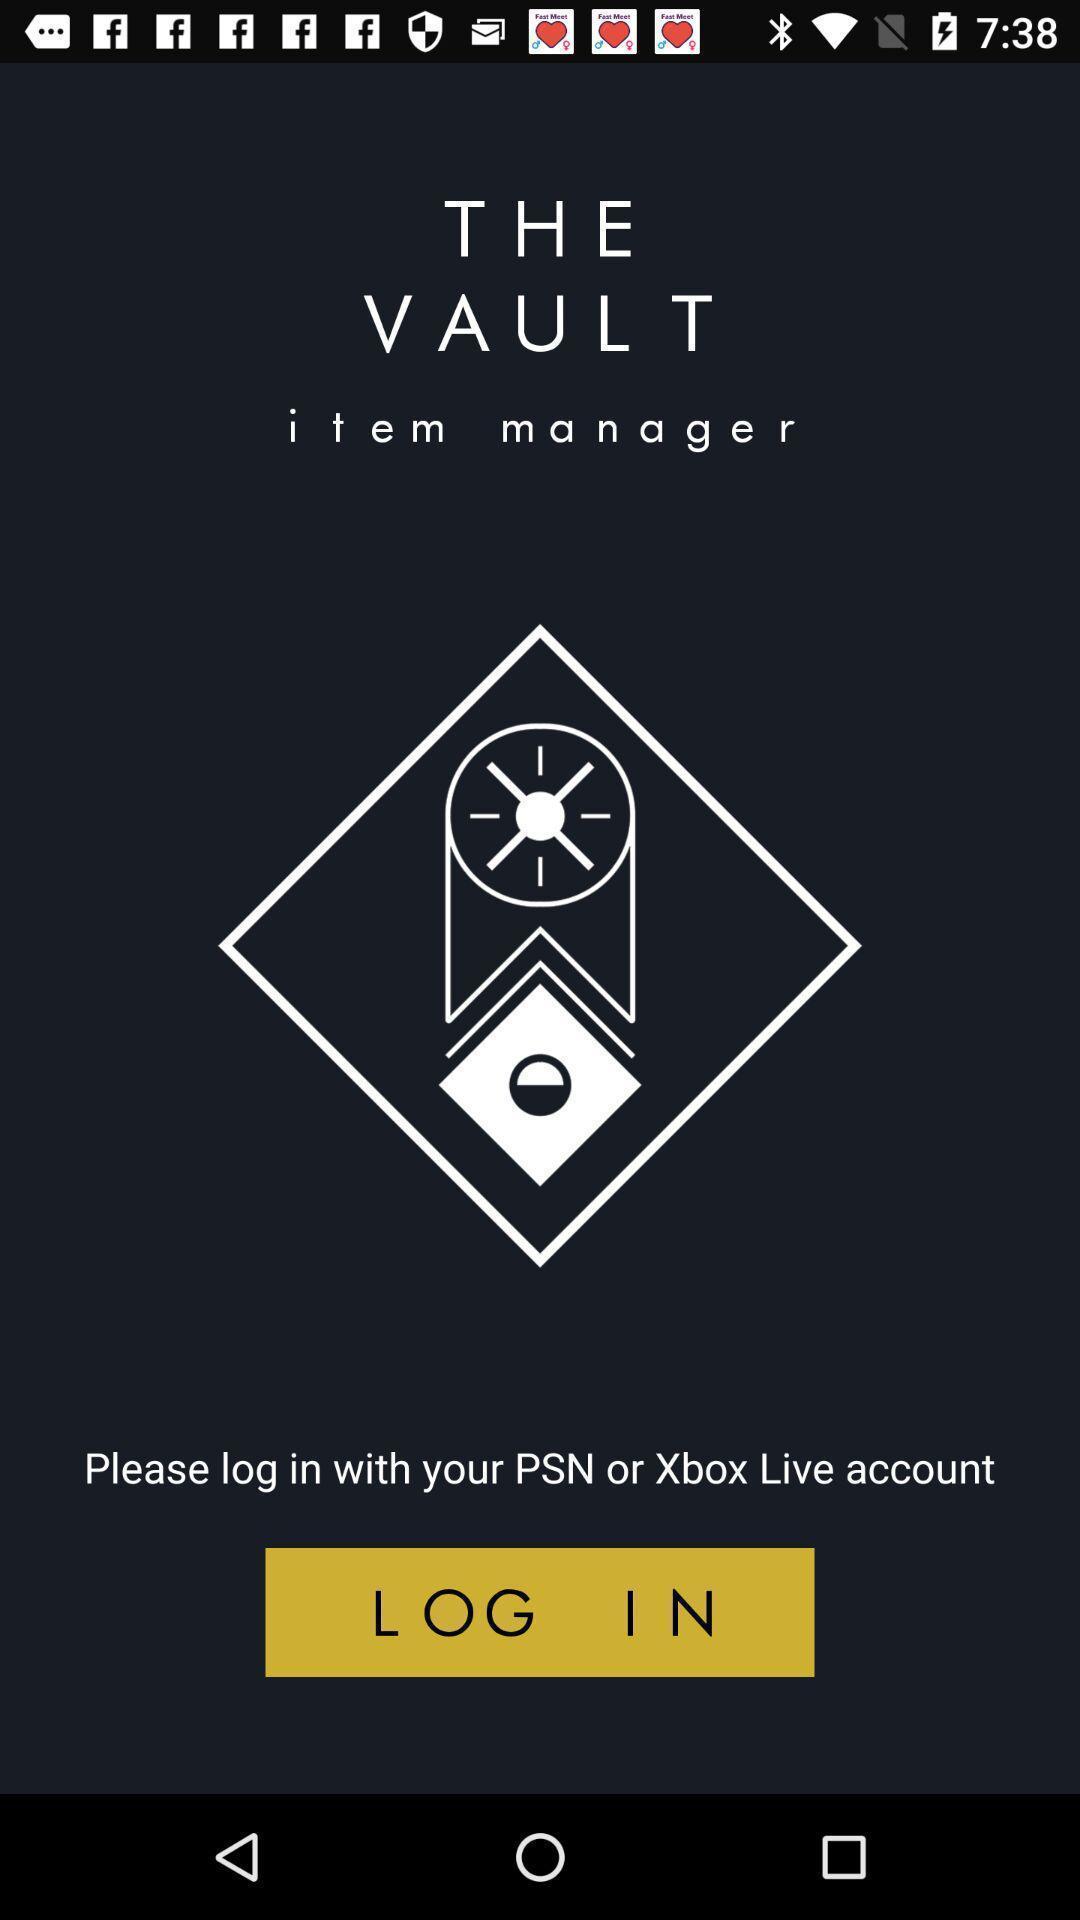What can you discern from this picture? Welcome page to login. 